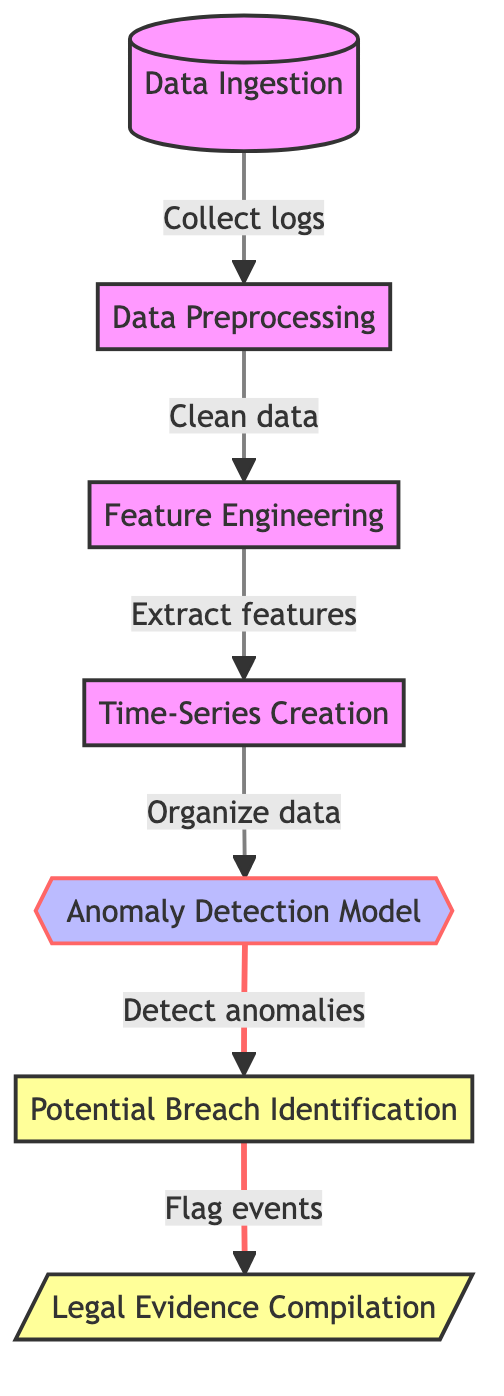What is the first step in the diagram? The diagram clearly shows the first node labeled "Data Ingestion" at the top, indicating the initial step in the process.
Answer: Data Ingestion How many main processes are depicted in the diagram? There are a total of six main nodes representing processes in the diagram, which include data ingestion, preprocessing, feature engineering, time-series creation, anomaly detection model, and potential breach identification.
Answer: Six What is the purpose of the node labeled "Anomaly Detection Model"? The diagram identifies this node as a critical part of the process where anomalies in the user data access logs are detected, indicating potential breach events.
Answer: Detect anomalies What is the output of the "Potential Breach Identification" node? According to the diagram, the output for this node specifically leads to the next step, which is "Legal Evidence Compilation." This indicates the importance of the identified breaches for legal purposes.
Answer: Legal Evidence Compilation What are the last two steps in the flow of the diagram? Reviewing the flow of the diagram from the last to second-to-last nodes, it shows that after identifying potential breaches, the next step is compiling legal evidence, which is the final process depicted.
Answer: Flag events and Legal Evidence Compilation Which process includes "Clean data" as a task? By examining the connections in the diagram, it is evident that "Clean data" is an activity designated under the "Data Preprocessing" node, as it directly follows the "Data Ingestion" step.
Answer: Data Preprocessing What connects "Data Preprocessing" and "Feature Engineering"? The diagram illustrates a directed edge from "Data Preprocessing" to "Feature Engineering," indicating that the output from the cleaning process directly feeds into feature extraction.
Answer: Clean data What does the diagram show happens after "Time-Series Creation"? From the diagram structure, "Time-Series Creation" directly connects to the "Anomaly Detection Model," showing that timed data organization is necessary before anomaly detection begins.
Answer: Anomaly Detection Model How does "Potential Breach Identification" relate to "Flag events"? The diagram indicates a flow where the output of "Potential Breach Identification" leads directly to the process of flagging events, suggesting that breaches identified will be marked for further analysis or action.
Answer: Flag events 